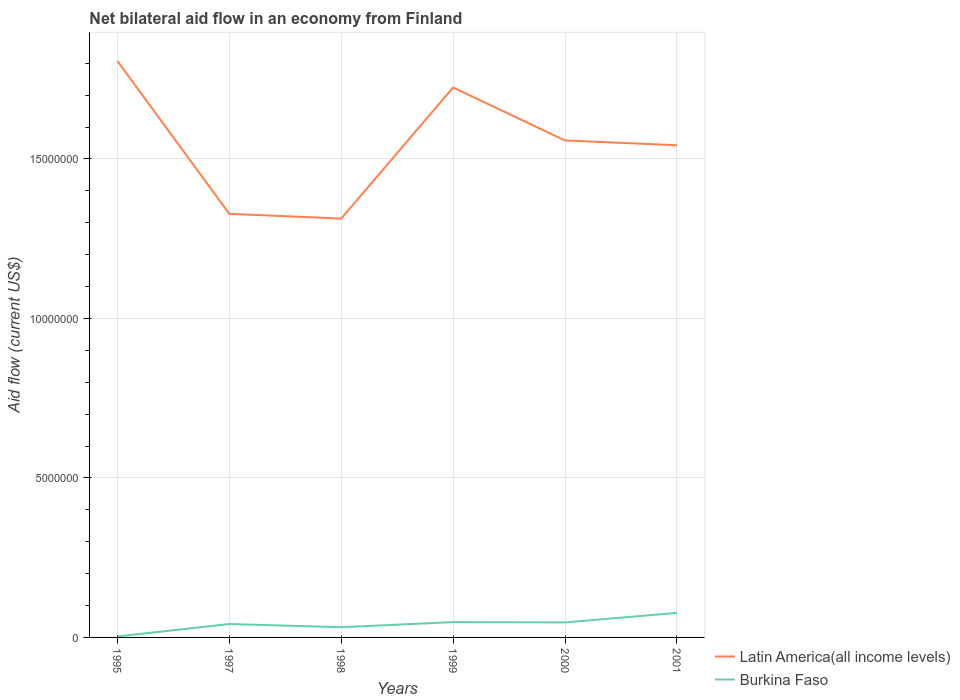How many different coloured lines are there?
Your answer should be very brief. 2. Is the number of lines equal to the number of legend labels?
Make the answer very short. Yes. Across all years, what is the maximum net bilateral aid flow in Latin America(all income levels)?
Provide a succinct answer. 1.31e+07. What is the total net bilateral aid flow in Latin America(all income levels) in the graph?
Provide a succinct answer. -2.45e+06. What is the difference between the highest and the second highest net bilateral aid flow in Latin America(all income levels)?
Keep it short and to the point. 4.94e+06. How many lines are there?
Your answer should be compact. 2. What is the difference between two consecutive major ticks on the Y-axis?
Make the answer very short. 5.00e+06. Does the graph contain any zero values?
Provide a succinct answer. No. How are the legend labels stacked?
Offer a very short reply. Vertical. What is the title of the graph?
Your answer should be very brief. Net bilateral aid flow in an economy from Finland. What is the label or title of the Y-axis?
Provide a succinct answer. Aid flow (current US$). What is the Aid flow (current US$) of Latin America(all income levels) in 1995?
Offer a terse response. 1.81e+07. What is the Aid flow (current US$) of Latin America(all income levels) in 1997?
Provide a short and direct response. 1.33e+07. What is the Aid flow (current US$) of Latin America(all income levels) in 1998?
Ensure brevity in your answer.  1.31e+07. What is the Aid flow (current US$) of Latin America(all income levels) in 1999?
Provide a short and direct response. 1.72e+07. What is the Aid flow (current US$) in Latin America(all income levels) in 2000?
Provide a succinct answer. 1.56e+07. What is the Aid flow (current US$) in Latin America(all income levels) in 2001?
Keep it short and to the point. 1.54e+07. What is the Aid flow (current US$) of Burkina Faso in 2001?
Your answer should be compact. 7.70e+05. Across all years, what is the maximum Aid flow (current US$) in Latin America(all income levels)?
Provide a succinct answer. 1.81e+07. Across all years, what is the maximum Aid flow (current US$) in Burkina Faso?
Provide a succinct answer. 7.70e+05. Across all years, what is the minimum Aid flow (current US$) of Latin America(all income levels)?
Give a very brief answer. 1.31e+07. What is the total Aid flow (current US$) in Latin America(all income levels) in the graph?
Give a very brief answer. 9.27e+07. What is the total Aid flow (current US$) in Burkina Faso in the graph?
Provide a succinct answer. 2.49e+06. What is the difference between the Aid flow (current US$) in Latin America(all income levels) in 1995 and that in 1997?
Your answer should be very brief. 4.79e+06. What is the difference between the Aid flow (current US$) of Burkina Faso in 1995 and that in 1997?
Your response must be concise. -3.90e+05. What is the difference between the Aid flow (current US$) of Latin America(all income levels) in 1995 and that in 1998?
Offer a terse response. 4.94e+06. What is the difference between the Aid flow (current US$) in Burkina Faso in 1995 and that in 1998?
Offer a very short reply. -2.90e+05. What is the difference between the Aid flow (current US$) in Latin America(all income levels) in 1995 and that in 1999?
Provide a short and direct response. 8.30e+05. What is the difference between the Aid flow (current US$) of Burkina Faso in 1995 and that in 1999?
Provide a short and direct response. -4.50e+05. What is the difference between the Aid flow (current US$) in Latin America(all income levels) in 1995 and that in 2000?
Your answer should be very brief. 2.49e+06. What is the difference between the Aid flow (current US$) of Burkina Faso in 1995 and that in 2000?
Your answer should be very brief. -4.40e+05. What is the difference between the Aid flow (current US$) in Latin America(all income levels) in 1995 and that in 2001?
Make the answer very short. 2.64e+06. What is the difference between the Aid flow (current US$) of Burkina Faso in 1995 and that in 2001?
Provide a short and direct response. -7.40e+05. What is the difference between the Aid flow (current US$) in Latin America(all income levels) in 1997 and that in 1998?
Ensure brevity in your answer.  1.50e+05. What is the difference between the Aid flow (current US$) of Latin America(all income levels) in 1997 and that in 1999?
Ensure brevity in your answer.  -3.96e+06. What is the difference between the Aid flow (current US$) in Burkina Faso in 1997 and that in 1999?
Provide a short and direct response. -6.00e+04. What is the difference between the Aid flow (current US$) of Latin America(all income levels) in 1997 and that in 2000?
Keep it short and to the point. -2.30e+06. What is the difference between the Aid flow (current US$) of Burkina Faso in 1997 and that in 2000?
Offer a terse response. -5.00e+04. What is the difference between the Aid flow (current US$) in Latin America(all income levels) in 1997 and that in 2001?
Your answer should be compact. -2.15e+06. What is the difference between the Aid flow (current US$) of Burkina Faso in 1997 and that in 2001?
Your answer should be very brief. -3.50e+05. What is the difference between the Aid flow (current US$) in Latin America(all income levels) in 1998 and that in 1999?
Give a very brief answer. -4.11e+06. What is the difference between the Aid flow (current US$) in Latin America(all income levels) in 1998 and that in 2000?
Provide a succinct answer. -2.45e+06. What is the difference between the Aid flow (current US$) of Burkina Faso in 1998 and that in 2000?
Make the answer very short. -1.50e+05. What is the difference between the Aid flow (current US$) of Latin America(all income levels) in 1998 and that in 2001?
Provide a short and direct response. -2.30e+06. What is the difference between the Aid flow (current US$) of Burkina Faso in 1998 and that in 2001?
Provide a succinct answer. -4.50e+05. What is the difference between the Aid flow (current US$) of Latin America(all income levels) in 1999 and that in 2000?
Your answer should be compact. 1.66e+06. What is the difference between the Aid flow (current US$) of Burkina Faso in 1999 and that in 2000?
Make the answer very short. 10000. What is the difference between the Aid flow (current US$) of Latin America(all income levels) in 1999 and that in 2001?
Make the answer very short. 1.81e+06. What is the difference between the Aid flow (current US$) in Burkina Faso in 1999 and that in 2001?
Offer a very short reply. -2.90e+05. What is the difference between the Aid flow (current US$) in Latin America(all income levels) in 2000 and that in 2001?
Make the answer very short. 1.50e+05. What is the difference between the Aid flow (current US$) in Burkina Faso in 2000 and that in 2001?
Ensure brevity in your answer.  -3.00e+05. What is the difference between the Aid flow (current US$) of Latin America(all income levels) in 1995 and the Aid flow (current US$) of Burkina Faso in 1997?
Keep it short and to the point. 1.76e+07. What is the difference between the Aid flow (current US$) of Latin America(all income levels) in 1995 and the Aid flow (current US$) of Burkina Faso in 1998?
Provide a succinct answer. 1.78e+07. What is the difference between the Aid flow (current US$) of Latin America(all income levels) in 1995 and the Aid flow (current US$) of Burkina Faso in 1999?
Make the answer very short. 1.76e+07. What is the difference between the Aid flow (current US$) of Latin America(all income levels) in 1995 and the Aid flow (current US$) of Burkina Faso in 2000?
Your answer should be compact. 1.76e+07. What is the difference between the Aid flow (current US$) in Latin America(all income levels) in 1995 and the Aid flow (current US$) in Burkina Faso in 2001?
Your response must be concise. 1.73e+07. What is the difference between the Aid flow (current US$) in Latin America(all income levels) in 1997 and the Aid flow (current US$) in Burkina Faso in 1998?
Your response must be concise. 1.30e+07. What is the difference between the Aid flow (current US$) in Latin America(all income levels) in 1997 and the Aid flow (current US$) in Burkina Faso in 1999?
Make the answer very short. 1.28e+07. What is the difference between the Aid flow (current US$) in Latin America(all income levels) in 1997 and the Aid flow (current US$) in Burkina Faso in 2000?
Your answer should be very brief. 1.28e+07. What is the difference between the Aid flow (current US$) of Latin America(all income levels) in 1997 and the Aid flow (current US$) of Burkina Faso in 2001?
Provide a short and direct response. 1.25e+07. What is the difference between the Aid flow (current US$) in Latin America(all income levels) in 1998 and the Aid flow (current US$) in Burkina Faso in 1999?
Your answer should be compact. 1.26e+07. What is the difference between the Aid flow (current US$) in Latin America(all income levels) in 1998 and the Aid flow (current US$) in Burkina Faso in 2000?
Make the answer very short. 1.27e+07. What is the difference between the Aid flow (current US$) in Latin America(all income levels) in 1998 and the Aid flow (current US$) in Burkina Faso in 2001?
Provide a short and direct response. 1.24e+07. What is the difference between the Aid flow (current US$) in Latin America(all income levels) in 1999 and the Aid flow (current US$) in Burkina Faso in 2000?
Your answer should be very brief. 1.68e+07. What is the difference between the Aid flow (current US$) in Latin America(all income levels) in 1999 and the Aid flow (current US$) in Burkina Faso in 2001?
Ensure brevity in your answer.  1.65e+07. What is the difference between the Aid flow (current US$) of Latin America(all income levels) in 2000 and the Aid flow (current US$) of Burkina Faso in 2001?
Your answer should be very brief. 1.48e+07. What is the average Aid flow (current US$) in Latin America(all income levels) per year?
Make the answer very short. 1.55e+07. What is the average Aid flow (current US$) of Burkina Faso per year?
Provide a succinct answer. 4.15e+05. In the year 1995, what is the difference between the Aid flow (current US$) in Latin America(all income levels) and Aid flow (current US$) in Burkina Faso?
Provide a short and direct response. 1.80e+07. In the year 1997, what is the difference between the Aid flow (current US$) of Latin America(all income levels) and Aid flow (current US$) of Burkina Faso?
Your response must be concise. 1.29e+07. In the year 1998, what is the difference between the Aid flow (current US$) in Latin America(all income levels) and Aid flow (current US$) in Burkina Faso?
Provide a succinct answer. 1.28e+07. In the year 1999, what is the difference between the Aid flow (current US$) of Latin America(all income levels) and Aid flow (current US$) of Burkina Faso?
Offer a very short reply. 1.68e+07. In the year 2000, what is the difference between the Aid flow (current US$) in Latin America(all income levels) and Aid flow (current US$) in Burkina Faso?
Your response must be concise. 1.51e+07. In the year 2001, what is the difference between the Aid flow (current US$) in Latin America(all income levels) and Aid flow (current US$) in Burkina Faso?
Your response must be concise. 1.47e+07. What is the ratio of the Aid flow (current US$) in Latin America(all income levels) in 1995 to that in 1997?
Make the answer very short. 1.36. What is the ratio of the Aid flow (current US$) of Burkina Faso in 1995 to that in 1997?
Provide a short and direct response. 0.07. What is the ratio of the Aid flow (current US$) in Latin America(all income levels) in 1995 to that in 1998?
Your answer should be very brief. 1.38. What is the ratio of the Aid flow (current US$) of Burkina Faso in 1995 to that in 1998?
Provide a short and direct response. 0.09. What is the ratio of the Aid flow (current US$) in Latin America(all income levels) in 1995 to that in 1999?
Your answer should be compact. 1.05. What is the ratio of the Aid flow (current US$) in Burkina Faso in 1995 to that in 1999?
Your response must be concise. 0.06. What is the ratio of the Aid flow (current US$) of Latin America(all income levels) in 1995 to that in 2000?
Your answer should be very brief. 1.16. What is the ratio of the Aid flow (current US$) in Burkina Faso in 1995 to that in 2000?
Offer a very short reply. 0.06. What is the ratio of the Aid flow (current US$) of Latin America(all income levels) in 1995 to that in 2001?
Make the answer very short. 1.17. What is the ratio of the Aid flow (current US$) of Burkina Faso in 1995 to that in 2001?
Ensure brevity in your answer.  0.04. What is the ratio of the Aid flow (current US$) in Latin America(all income levels) in 1997 to that in 1998?
Offer a terse response. 1.01. What is the ratio of the Aid flow (current US$) of Burkina Faso in 1997 to that in 1998?
Make the answer very short. 1.31. What is the ratio of the Aid flow (current US$) in Latin America(all income levels) in 1997 to that in 1999?
Your response must be concise. 0.77. What is the ratio of the Aid flow (current US$) in Latin America(all income levels) in 1997 to that in 2000?
Keep it short and to the point. 0.85. What is the ratio of the Aid flow (current US$) of Burkina Faso in 1997 to that in 2000?
Make the answer very short. 0.89. What is the ratio of the Aid flow (current US$) in Latin America(all income levels) in 1997 to that in 2001?
Make the answer very short. 0.86. What is the ratio of the Aid flow (current US$) in Burkina Faso in 1997 to that in 2001?
Give a very brief answer. 0.55. What is the ratio of the Aid flow (current US$) of Latin America(all income levels) in 1998 to that in 1999?
Ensure brevity in your answer.  0.76. What is the ratio of the Aid flow (current US$) in Latin America(all income levels) in 1998 to that in 2000?
Your response must be concise. 0.84. What is the ratio of the Aid flow (current US$) in Burkina Faso in 1998 to that in 2000?
Keep it short and to the point. 0.68. What is the ratio of the Aid flow (current US$) in Latin America(all income levels) in 1998 to that in 2001?
Provide a short and direct response. 0.85. What is the ratio of the Aid flow (current US$) of Burkina Faso in 1998 to that in 2001?
Your response must be concise. 0.42. What is the ratio of the Aid flow (current US$) in Latin America(all income levels) in 1999 to that in 2000?
Ensure brevity in your answer.  1.11. What is the ratio of the Aid flow (current US$) in Burkina Faso in 1999 to that in 2000?
Provide a succinct answer. 1.02. What is the ratio of the Aid flow (current US$) in Latin America(all income levels) in 1999 to that in 2001?
Make the answer very short. 1.12. What is the ratio of the Aid flow (current US$) of Burkina Faso in 1999 to that in 2001?
Offer a very short reply. 0.62. What is the ratio of the Aid flow (current US$) in Latin America(all income levels) in 2000 to that in 2001?
Make the answer very short. 1.01. What is the ratio of the Aid flow (current US$) of Burkina Faso in 2000 to that in 2001?
Your answer should be very brief. 0.61. What is the difference between the highest and the second highest Aid flow (current US$) of Latin America(all income levels)?
Ensure brevity in your answer.  8.30e+05. What is the difference between the highest and the second highest Aid flow (current US$) of Burkina Faso?
Provide a short and direct response. 2.90e+05. What is the difference between the highest and the lowest Aid flow (current US$) in Latin America(all income levels)?
Your response must be concise. 4.94e+06. What is the difference between the highest and the lowest Aid flow (current US$) in Burkina Faso?
Ensure brevity in your answer.  7.40e+05. 